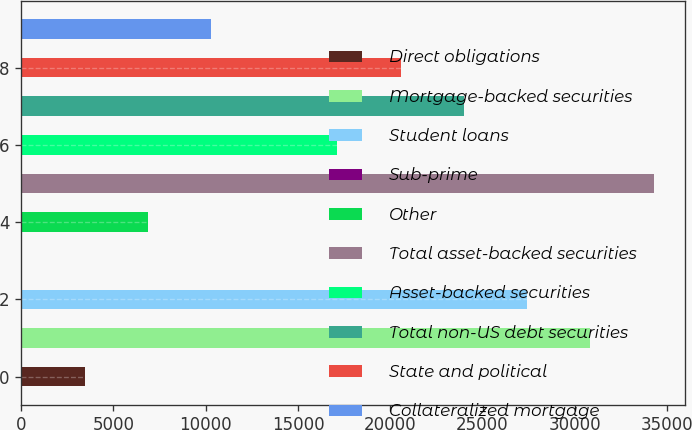Convert chart. <chart><loc_0><loc_0><loc_500><loc_500><bar_chart><fcel>Direct obligations<fcel>Mortgage-backed securities<fcel>Student loans<fcel>Sub-prime<fcel>Other<fcel>Total asset-backed securities<fcel>Asset-backed securities<fcel>Total non-US debt securities<fcel>State and political<fcel>Collateralized mortgage<nl><fcel>3441.7<fcel>30839.3<fcel>27414.6<fcel>17<fcel>6866.4<fcel>34264<fcel>17140.5<fcel>23989.9<fcel>20565.2<fcel>10291.1<nl></chart> 